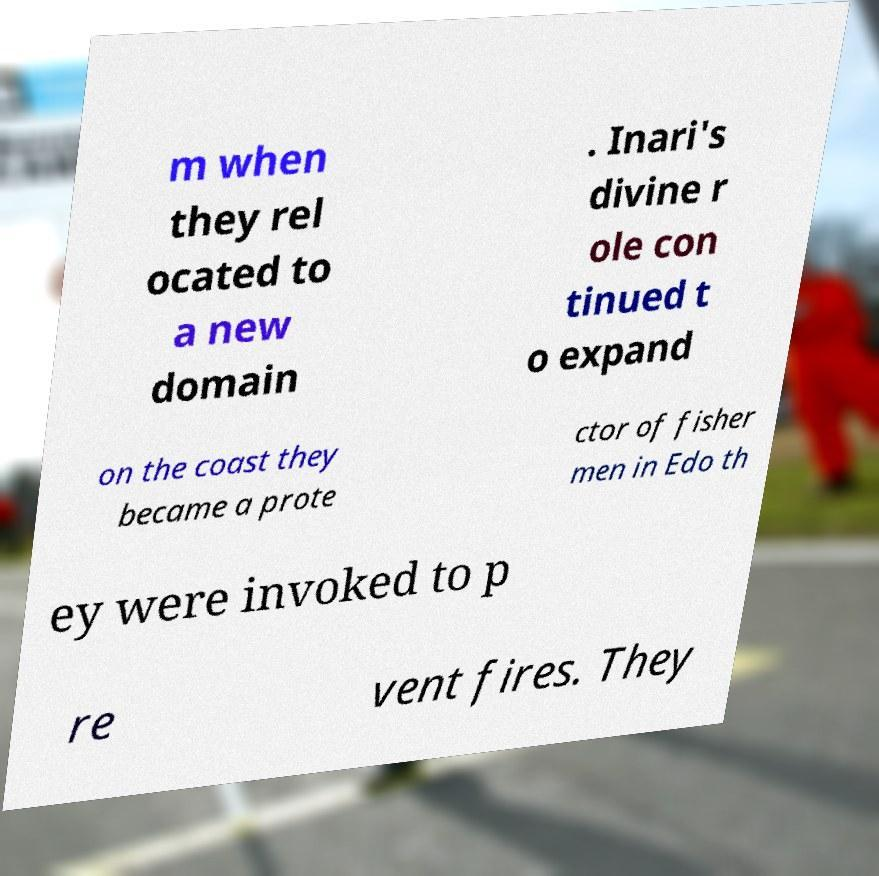For documentation purposes, I need the text within this image transcribed. Could you provide that? m when they rel ocated to a new domain . Inari's divine r ole con tinued t o expand on the coast they became a prote ctor of fisher men in Edo th ey were invoked to p re vent fires. They 